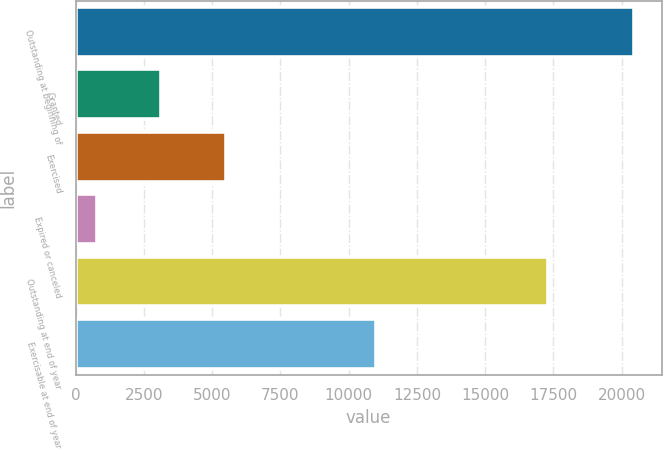Convert chart. <chart><loc_0><loc_0><loc_500><loc_500><bar_chart><fcel>Outstanding at beginning of<fcel>Granted<fcel>Exercised<fcel>Expired or canceled<fcel>Outstanding at end of year<fcel>Exercisable at end of year<nl><fcel>20443<fcel>3126<fcel>5490<fcel>770<fcel>17309<fcel>11016<nl></chart> 